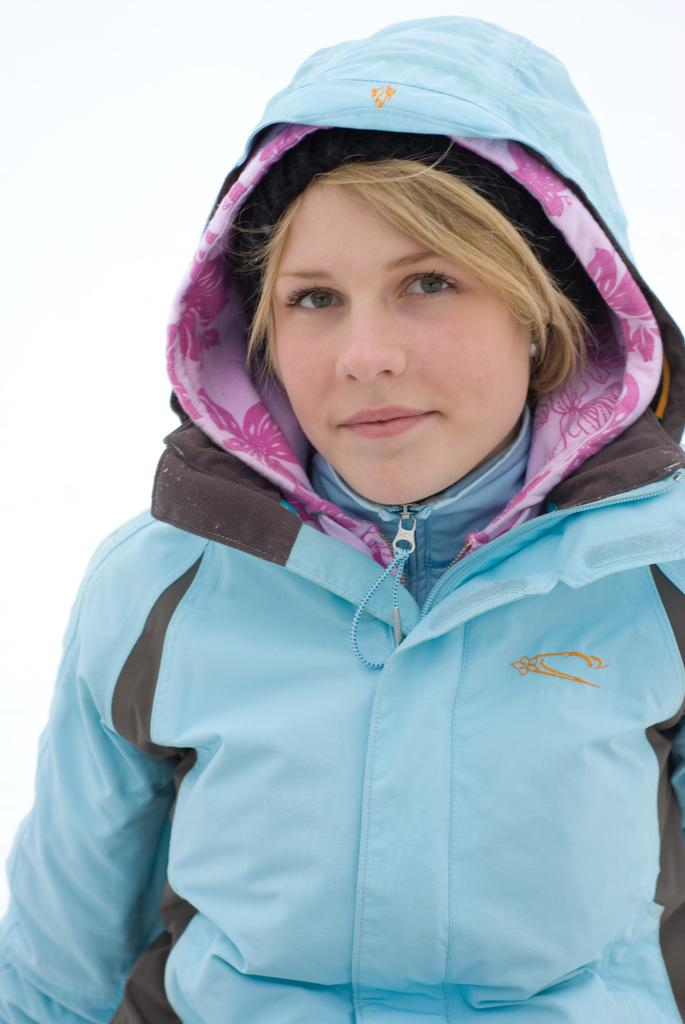Who is the main subject in the image? There is a woman in the image. What is the woman doing in the image? The woman is standing. What is the woman wearing in the image? The woman is wearing a blue jacket. What color is the cub's nose in the image? There is no cub present in the image, so it is not possible to determine the color of its nose. 